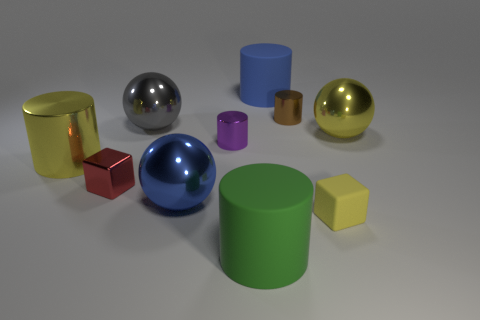How many red objects are either small metallic objects or tiny metallic cylinders?
Provide a short and direct response. 1. Are there more yellow cylinders than big blue metal cylinders?
Offer a very short reply. Yes. There is another metal cylinder that is the same size as the blue cylinder; what is its color?
Offer a very short reply. Yellow. How many cylinders are large green matte objects or big yellow metallic objects?
Ensure brevity in your answer.  2. Does the big green object have the same shape as the big matte thing behind the big metal cylinder?
Provide a short and direct response. Yes. What number of green cylinders are the same size as the gray shiny ball?
Make the answer very short. 1. There is a large thing in front of the blue ball; does it have the same shape as the purple thing right of the blue ball?
Provide a short and direct response. Yes. There is a large shiny thing that is the same color as the large metallic cylinder; what shape is it?
Provide a short and direct response. Sphere. The big metal thing in front of the big yellow shiny object left of the tiny red metallic block is what color?
Make the answer very short. Blue. There is a tiny matte thing that is the same shape as the small red metallic object; what color is it?
Provide a short and direct response. Yellow. 